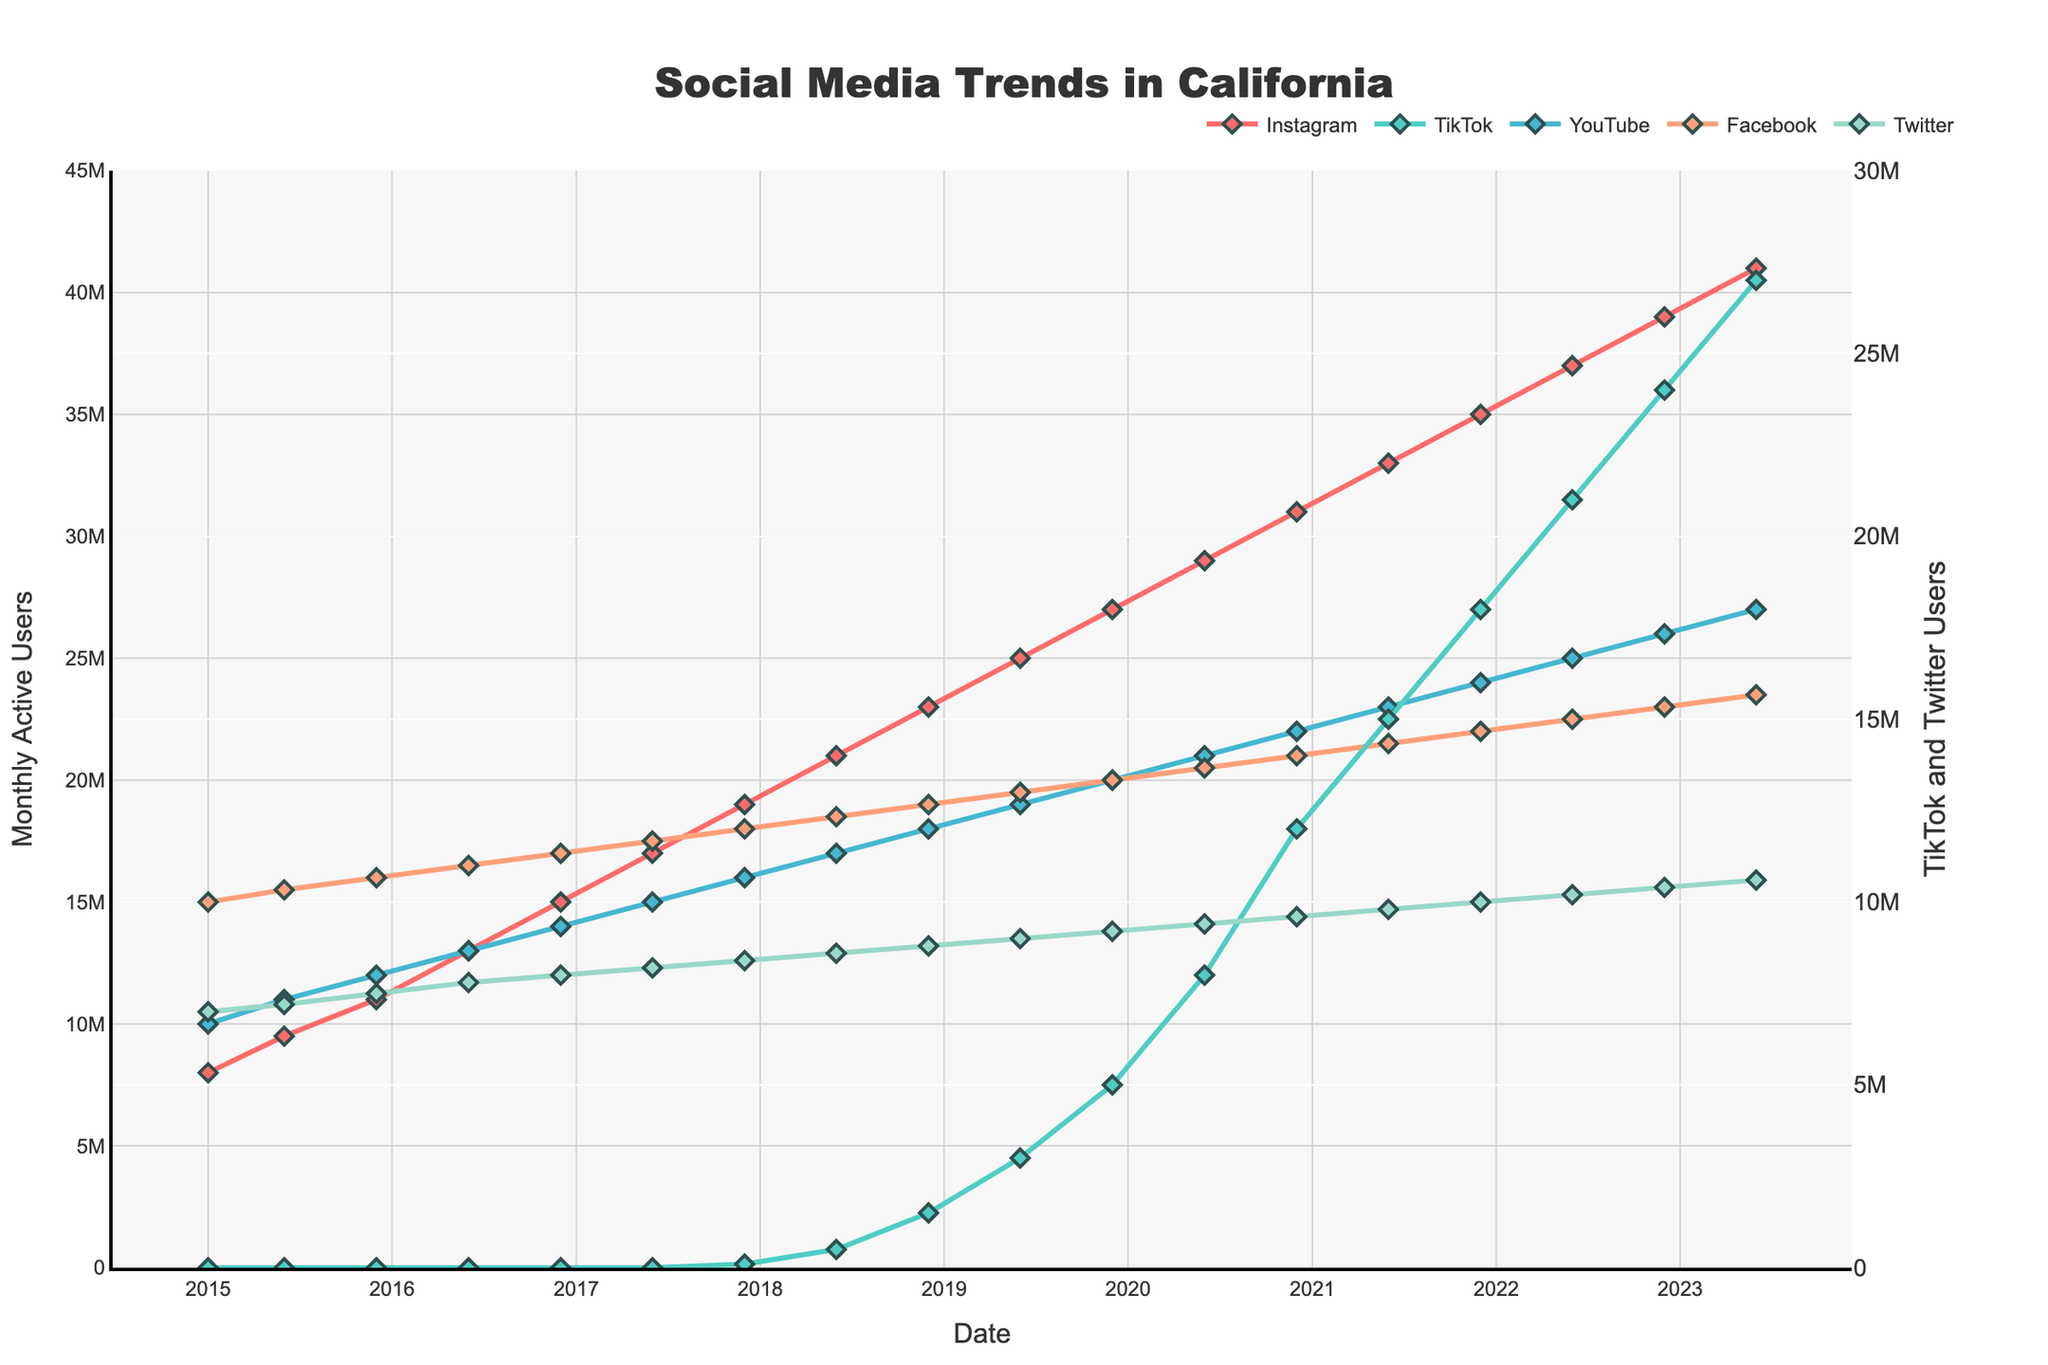Which social media app had the most significant growth in monthly active users from 2015 to 2023? To identify the app with the most significant growth, compare the initial and final values for each app. Instagram grew from 8,000,000 to 41,000,000, TikTok from 0 to 27,000,000, YouTube from 10,000,000 to 27,000,000, Facebook from 15,000,000 to 23,500,000, and Twitter from 7,000,000 to 10,600,000. Instagram had the largest increase.
Answer: Instagram What was the monthly active user count for TikTok in December 2017? Look for the data point for TikTok corresponding to December 2017. The count was 100,000 users.
Answer: 100,000 How did the monthly active users for Instagram compare to YouTube in June 2019? In June 2019, compare the values for Instagram and YouTube. Instagram had 25,000,000 users, and YouTube had 19,000,000 users. Instagram had more users.
Answer: Instagram had more users What's the average monthly active users for Facebook from 2015 to 2023? Sum the monthly active users for Facebook across all the given points and divide by the number of points. The sum is 291,000,000 (15,000,000 + 15,500,000 + 16,000,000 + 16,500,000 + 17,000,000 + 17,500,000 + 18,000,000 + 18,500,000 + 19,000,000 + 19,500,000 + 20,000,000 + 20,500,000 + 21,000,000 + 21,500,000 + 22,000,000 + 22,500,000 + 23,000,000 + 23,500,000) and there are 18 points. The average is 291,000,000/18 = 16,166,667.
Answer: 16,166,667 Which app had the least growth in monthly active users from 2015 to 2023? Compare the growth in users for each app over the given period. Twitter increased from 7,000,000 to 10,600,000, showing the least growth.
Answer: Twitter By how much did YouTube's monthly active users increase from June 2018 to December 2020? In June 2018, YouTube had 17,000,000 users, and by December 2020, it had 22,000,000 users. The increase is 22,000,000 - 17,000,000 = 5,000,000.
Answer: 5,000,000 Which two social media apps had nearly parallel growth trends from 2015 to 2023? By visually inspecting the lines, Instagram and Facebook show similar trends and parallel growth.
Answer: Instagram and Facebook In June 2018, which app had the second-highest number of monthly active users? Examine the user counts in June 2018. The counts were Instagram (21,000,000), TikTok (500,000), YouTube (17,000,000), Facebook (18,500,000), and Twitter (8,600,000). Facebook had the second-highest number of users.
Answer: Facebook What's the difference in monthly active users for Instagram between June 2015 and June 2022? In June 2015, Instagram had 9,500,000 users, and in June 2022, it had 37,000,000 users. The difference is 37,000,000 - 9,500,000 = 27,500,000.
Answer: 27,500,000 How does TikTok's growth in users compare from 2017 to 2023 relative to Instagram's growth in the same period? TikTok grew from 0 to 27,000,000 users, an increase of 27,000,000 users. Instagram grew from 19,000,000 to 41,000,000 users, an increase of 22,000,000. TikTok showed a greater growth difference in this period.
Answer: TikTok showed greater growth 